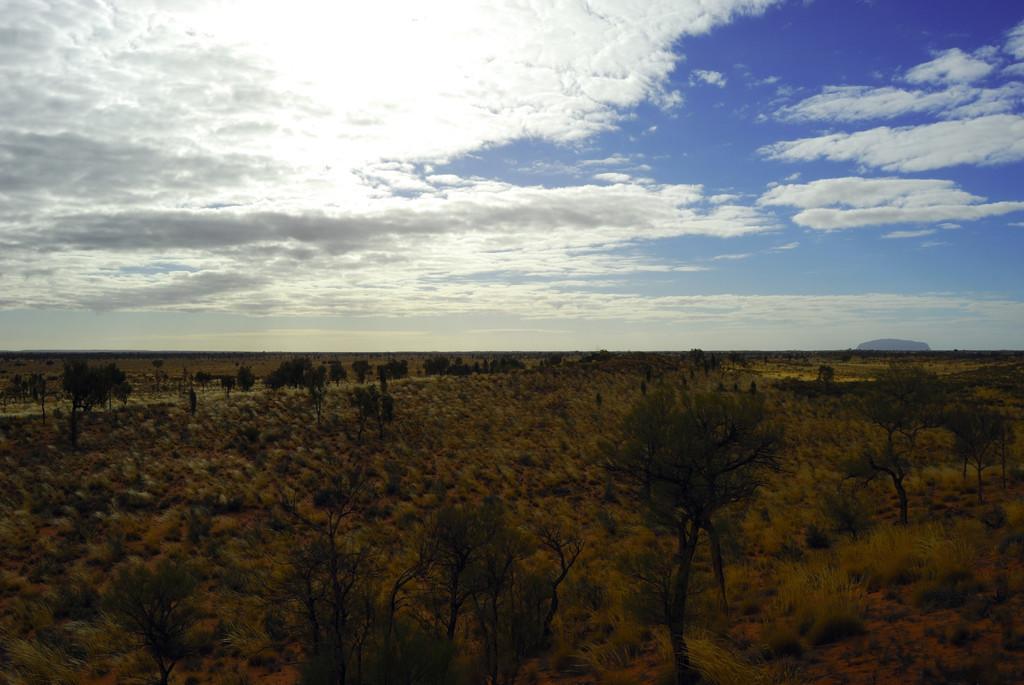Please provide a concise description of this image. This image is taken outdoors. At the top of the image there is the sky with clouds. At the bottom of the image there is a ground with grass on it and there are many trees and plants with leaves, stems and branches. 